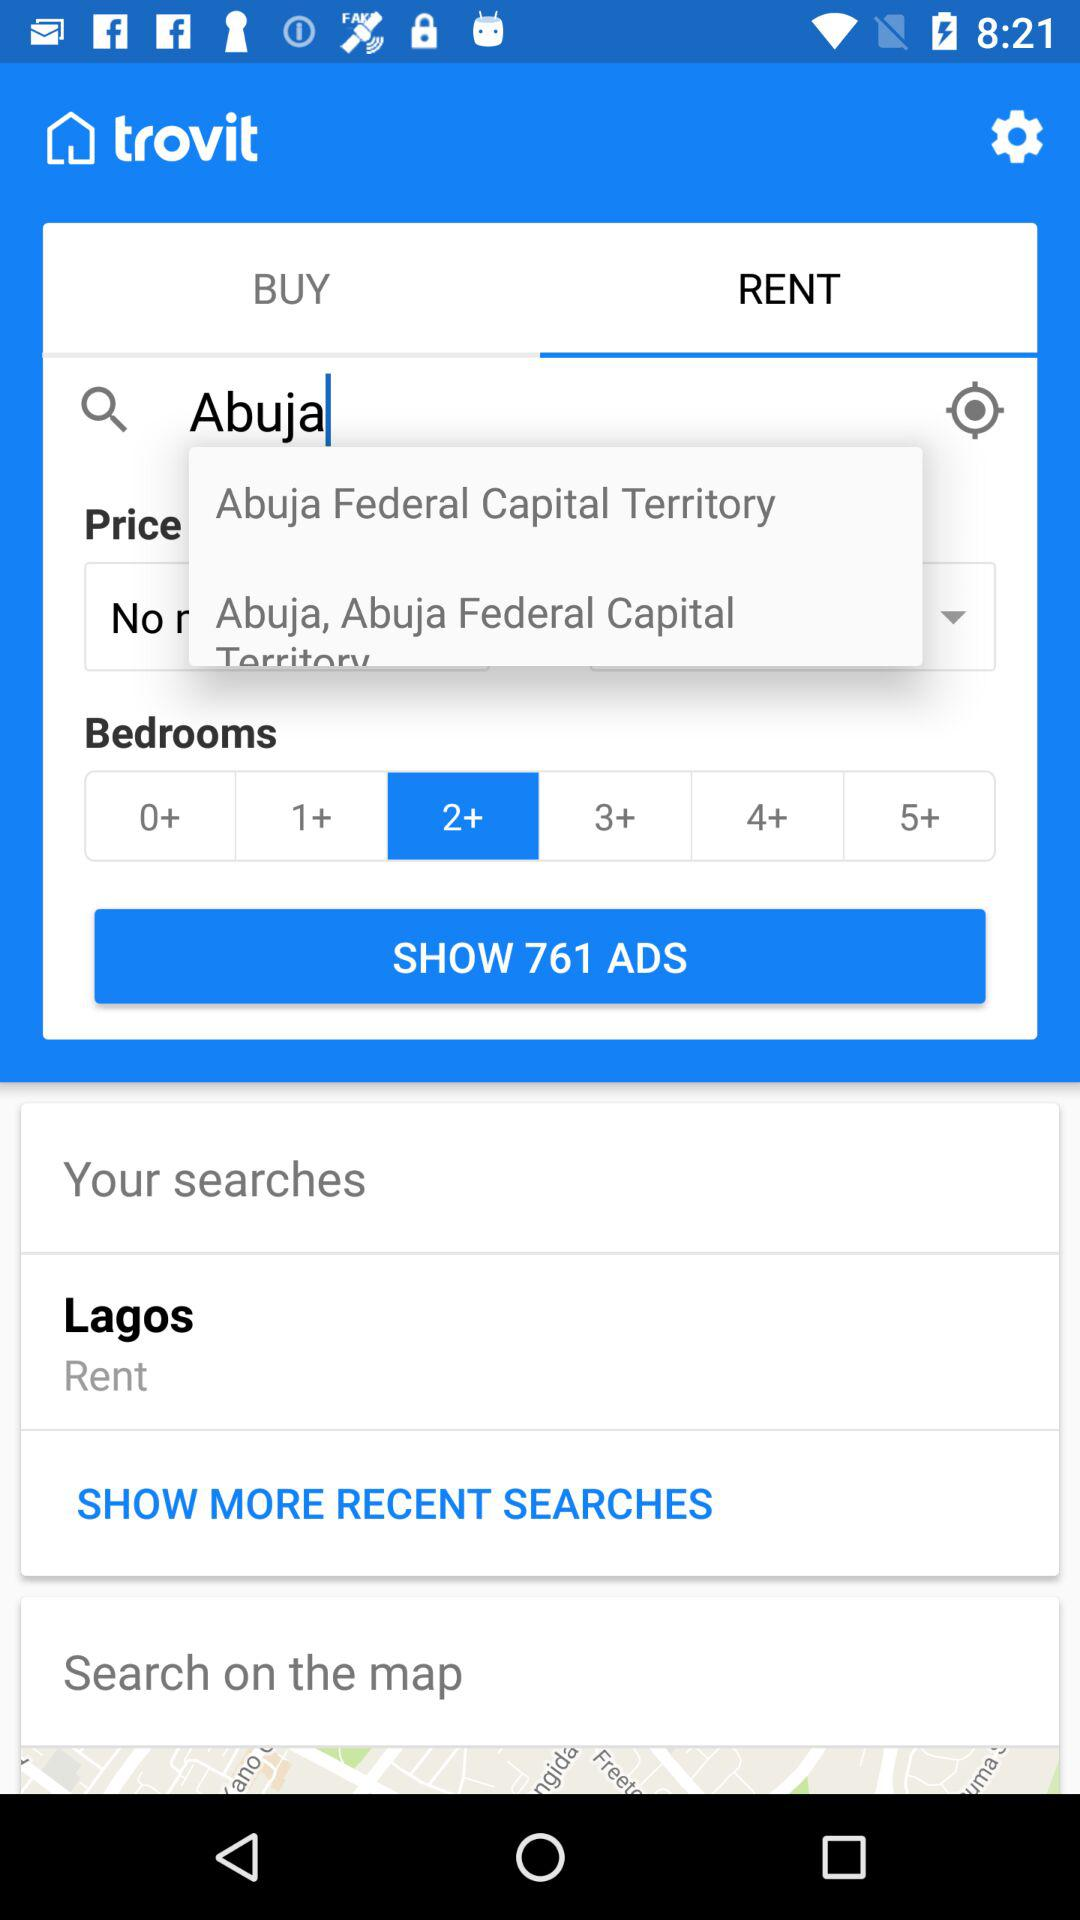What is the entered location? The entered location is Abuja. 